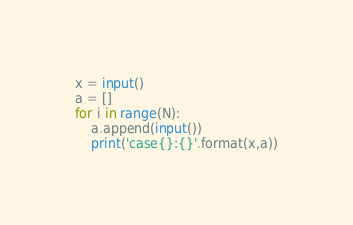<code> <loc_0><loc_0><loc_500><loc_500><_Python_>x = input()
a = []
for i in range(N):
    a.append(input())
    print('case{}:{}'.format(x,a))</code> 